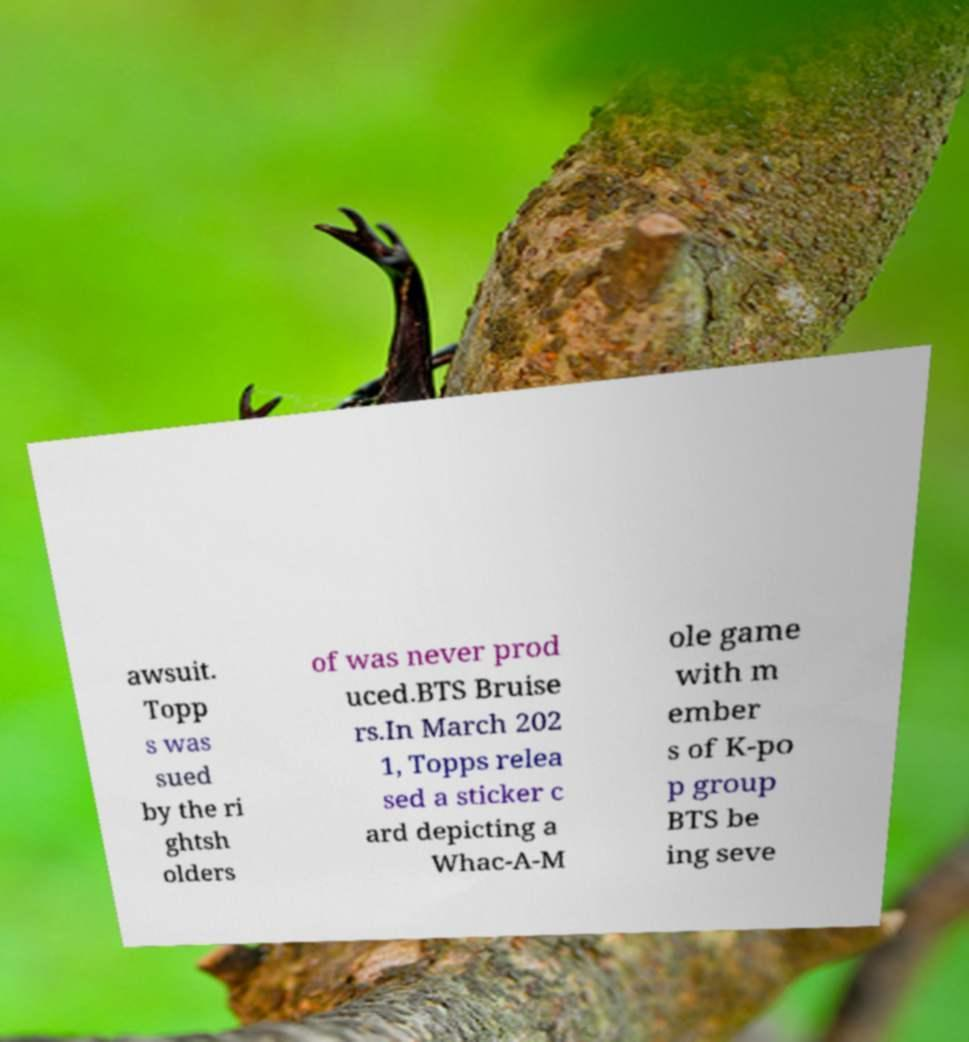Can you read and provide the text displayed in the image?This photo seems to have some interesting text. Can you extract and type it out for me? awsuit. Topp s was sued by the ri ghtsh olders of was never prod uced.BTS Bruise rs.In March 202 1, Topps relea sed a sticker c ard depicting a Whac-A-M ole game with m ember s of K-po p group BTS be ing seve 